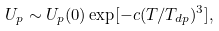<formula> <loc_0><loc_0><loc_500><loc_500>U _ { p } \sim U _ { p } ( 0 ) \exp [ - c ( T / T _ { d p } ) ^ { 3 } ] ,</formula> 